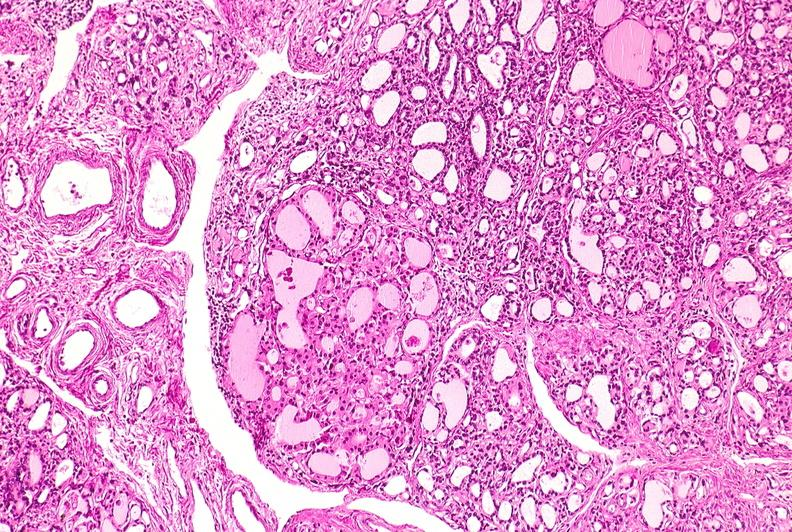what does this image show?
Answer the question using a single word or phrase. Thyroid 